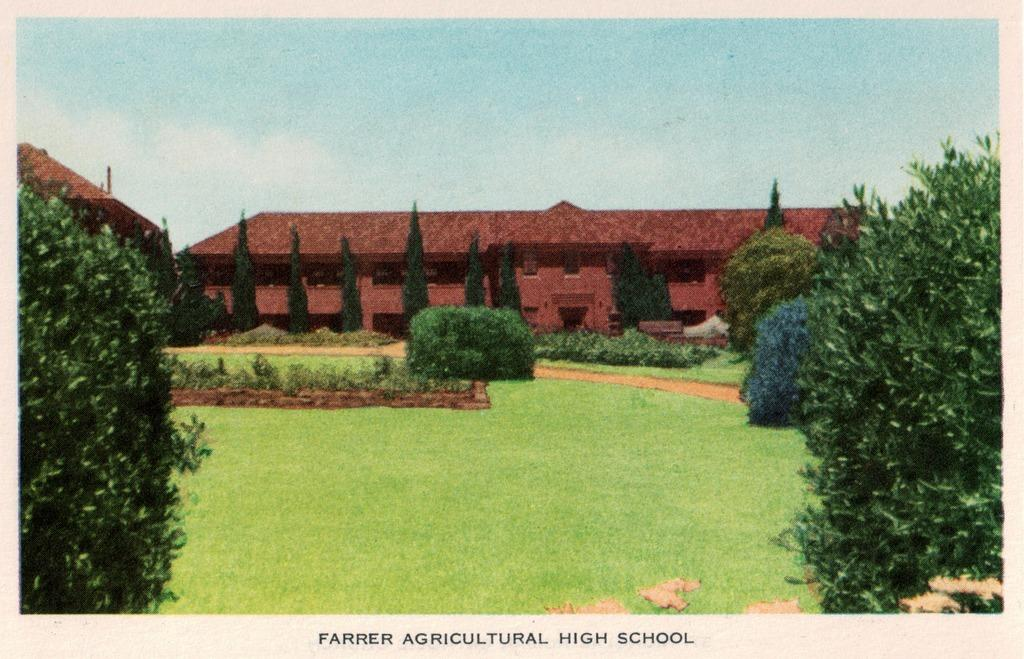What is depicted on the paper in the image? The paper contains a drawing or image. What elements can be seen in the drawing or image? The drawing or image includes buildings, trees, and plants. What is visible behind the buildings in the drawing or image? The sky is visible behind the buildings in the drawing or image. Is there any text on the paper? Yes, there is writing on the paper. What type of zephyr is blowing through the buildings in the image? There is no mention of a zephyr or any wind in the image; it only shows a drawing or image with buildings, trees, plants, and the sky. 